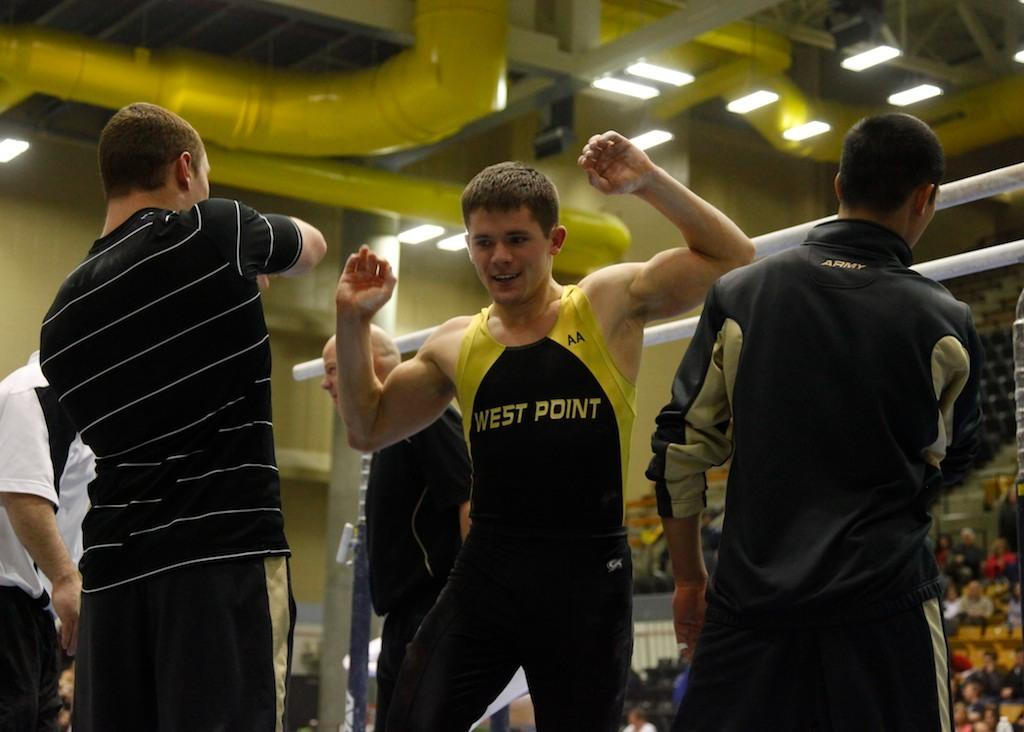<image>
Describe the image concisely. a boy has the term west point on his outfit 